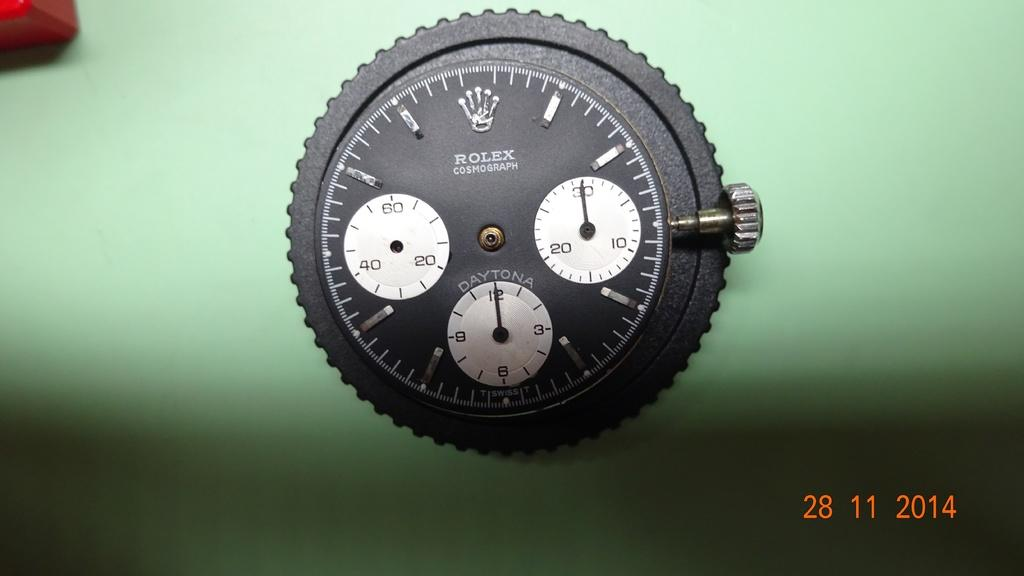<image>
Relay a brief, clear account of the picture shown. A Rolex watch face sits on a green table. 